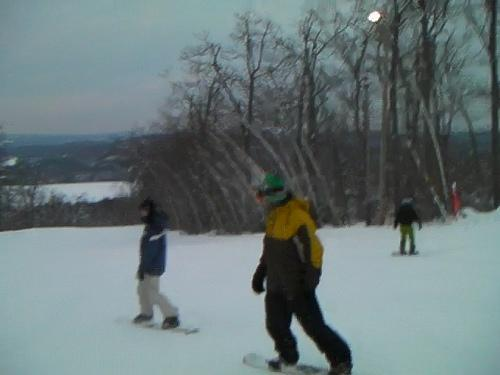What does the white light come from?

Choices:
A) star
B) lamp
C) moon
D) sun lamp 